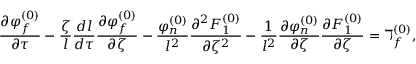Convert formula to latex. <formula><loc_0><loc_0><loc_500><loc_500>\frac { \partial \varphi _ { f } ^ { ( 0 ) } } { \partial \tau } - \frac { \zeta } { l } \frac { d l } { d \tau } \frac { \partial \varphi _ { f } ^ { ( 0 ) } } { \partial \zeta } - \frac { \varphi _ { n } ^ { ( 0 ) } } { l ^ { 2 } } \frac { \partial ^ { 2 } F _ { 1 } ^ { ( 0 ) } } { \partial \zeta ^ { 2 } } - \frac { 1 } { l ^ { 2 } } \frac { \partial \varphi _ { n } ^ { ( 0 ) } } { \partial \zeta } \frac { \partial F _ { 1 } ^ { ( 0 ) } } { \partial \zeta } = \daleth _ { f } ^ { ( 0 ) } ,</formula> 